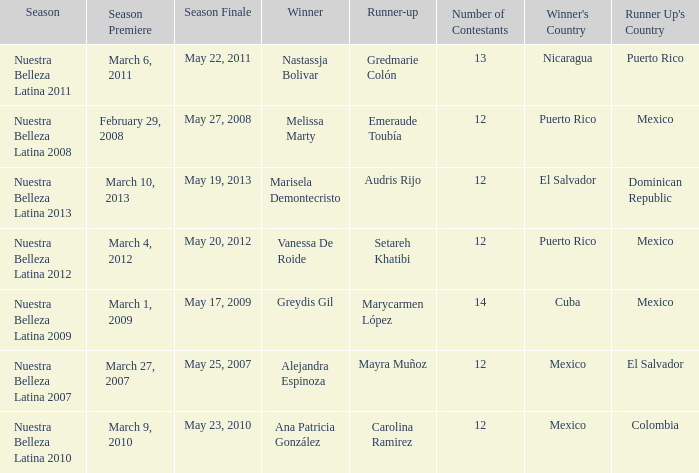What season had mexico as the runner up with melissa marty winning? Nuestra Belleza Latina 2008. 